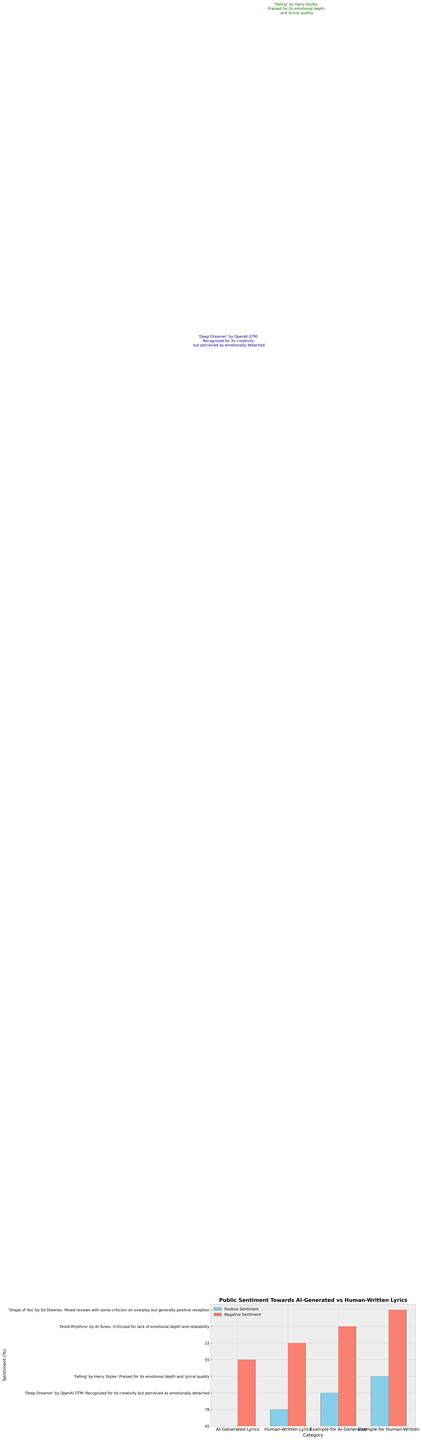What is the total positive sentiment percentage across both AI-Generated and Human-Written Lyrics? To find the total positive sentiment percentage, add the positive sentiment for both AI-Generated Lyrics and Human-Written Lyrics: 45% (AI-Generated) + 78% (Human-Written) = 123%.
Answer: 123% Which category has a higher negative sentiment percentage? Compare the negative sentiment percentages of AI-Generated Lyrics and Human-Written Lyrics. AI-Generated Lyrics have 55% negative sentiment, while Human-Written Lyrics have 22% negative sentiment. Therefore, AI-Generated Lyrics have a higher negative sentiment percentage.
Answer: AI-Generated Lyrics By how much does the positive sentiment percentage for Human-Written Lyrics exceed that of AI-Generated Lyrics? The positive sentiment for Human-Written Lyrics is 78%, and for AI-Generated Lyrics, it is 45%. Subtract the positive sentiment of AI-Generated Lyrics from that of Human-Written Lyrics: 78% - 45% = 33%.
Answer: 33% What color is used to represent negative sentiment in the bar chart? The bars representing negative sentiment are colored salmon in the chart.
Answer: Salmon Compare the annotated comments for AI-Generated Lyrics and Human-Written Lyrics, and identify which characteristic is highlighted for AI-generated in the annotation. The annotation for AI-Generated Lyrics mentions "'Deep Dreamer' by OpenAI GTM: Recognized for its creativity but perceived as emotionally detached." The highlighted characteristic is creativity but emotionally detached.
Answer: Creativity but emotionally detached How much higher is the negative sentiment percentage for AI-Generated Lyrics compared to Human-Written Lyrics? Subtract the negative sentiment percentage of Human-Written Lyrics (22%) from that of AI-Generated Lyrics (55%): 55% - 22% = 33%.
Answer: 33% What percentage of sentiment for AI-Generated Lyrics is not positive? Since the total sentiment percentage is 100%, subtract the positive sentiment (45%) from 100% to find the percentage that is not positive: 100% - 45% = 55%.
Answer: 55% Which specific example of a Human-Written song was praised for its emotional depth and lyrical quality, according to the annotations? The annotation for Human-Written Lyrics mentions "'Falling' by Harry Styles: Praised for its emotional depth and lyrical quality."
Answer: 'Falling' by Harry Styles 